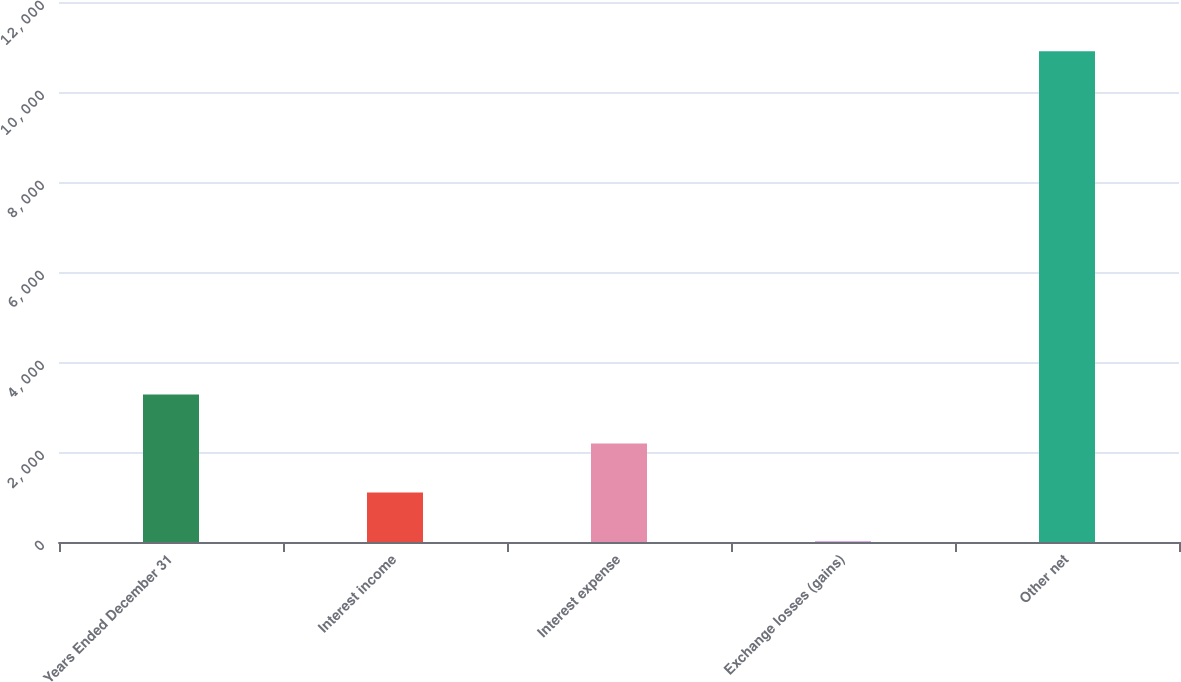<chart> <loc_0><loc_0><loc_500><loc_500><bar_chart><fcel>Years Ended December 31<fcel>Interest income<fcel>Interest expense<fcel>Exchange losses (gains)<fcel>Other net<nl><fcel>3280.2<fcel>1101.4<fcel>2190.8<fcel>12<fcel>10906<nl></chart> 